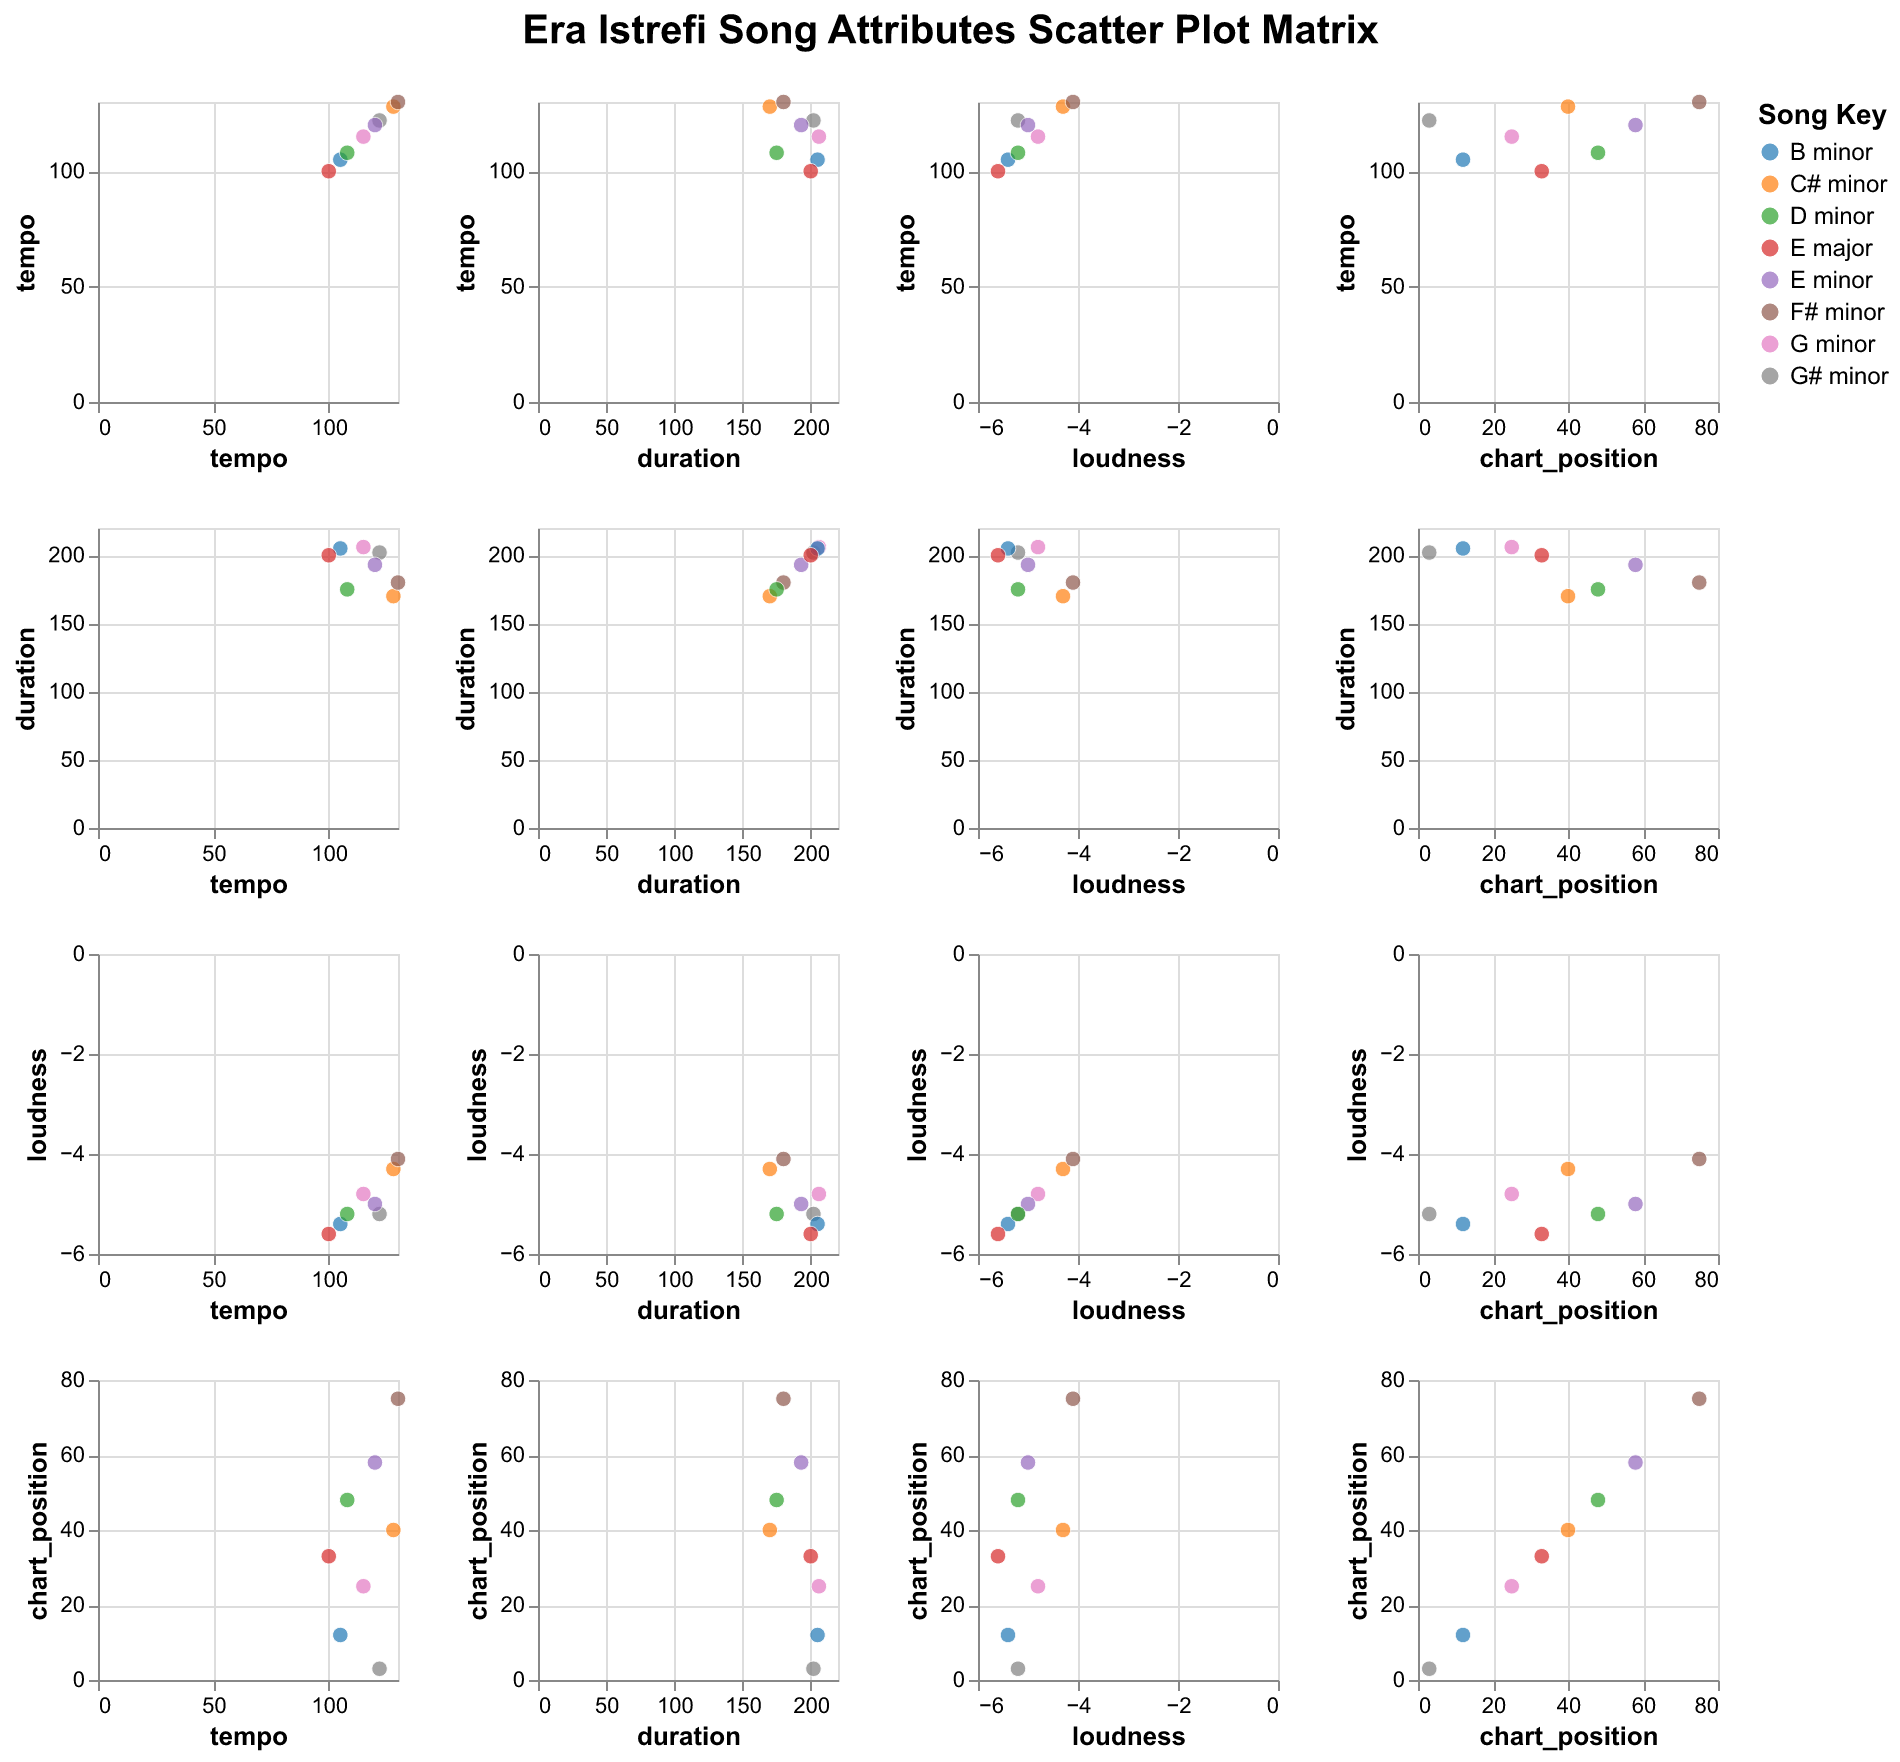What's the title of the figure? The title is displayed at the top of the figure.
Answer: Era Istrefi Song Attributes Scatter Plot Matrix How many songs are displayed in the scatter plot matrix? There are 8 distinct song titles listed in the data, which correspond to 8 data points in the plot.
Answer: 8 Which song has the highest tempo? The figure provides the tempo for each song in the 'tempo' vs 'chart position' subplot. The song with the highest tempo value is "Origami" with a tempo of 130.
Answer: Origami What is the average duration of the songs in the dataset? First, convert all durations to seconds: Bonbon (202), No I Love Yous (206), Redrum (170), Prisoner (193), Njo Si Ti (205), Origami (180), Nuk E Di (200), Shume Pis (175). Sum these up: 202 + 206 + 170 + 193 + 205 + 180 + 200 + 175 = 1531. The average duration is 1531/8 = 191.375 seconds.
Answer: 191.375 seconds Which song has the least chart position? In the 'chart position' axis across different plots, the song with the lowest chart position is "Bonbon" with the value of 3, indicating the highest rank.
Answer: Bonbon Is there a noticeable relationship between tempo and chart position? By examining the 'tempo' vs 'chart position' plot, there doesn't appear to be any clear pattern that suggests a relationship between tempo and chart position. The data points are quite scattered.
Answer: No noticeable relationship Which song has the highest loudness? To find the highest loudness, check the 'loudness' vs 'chart position' plot. The highest loudness value is from "Origami" with a loudness of -4.1.
Answer: Origami Do songs with longer durations tend to have higher chart positions? Observing the 'duration' vs 'chart position' plot, the songs with varying durations don't display a clear trend indicating that longer durations lead to higher chart positions.
Answer: No clear trend What is the most common song key in the dataset? The most common song key can be determined by the color legend. Each key assigns a different color. "E minor" and "B minor" each appear twice, making them the most common keys.
Answer: E minor, B minor How does the song "Bonbon" compare to "No I Love Yous" in terms of loudness and chart position? In the 'loudness' vs 'chart position' plot, "Bonbon" has a loudness of -5.2 and a chart position of 3, while "No I Love Yous" has a loudness of -4.8 and a chart position of 25. "Bonbon" is quieter but performed better on the charts.
Answer: Bonbon: quieter, better chart position 